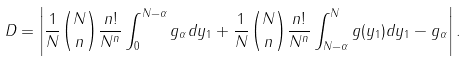<formula> <loc_0><loc_0><loc_500><loc_500>D = \left | \frac { 1 } { N } \binom { N } { n } \frac { n ! } { N ^ { n } } \int _ { 0 } ^ { N - \alpha } g _ { \alpha } d y _ { 1 } + \frac { 1 } { N } \binom { N } { n } \frac { n ! } { N ^ { n } } \int _ { N - \alpha } ^ { N } g ( y _ { 1 } ) d y _ { 1 } - g _ { \alpha } \right | .</formula> 